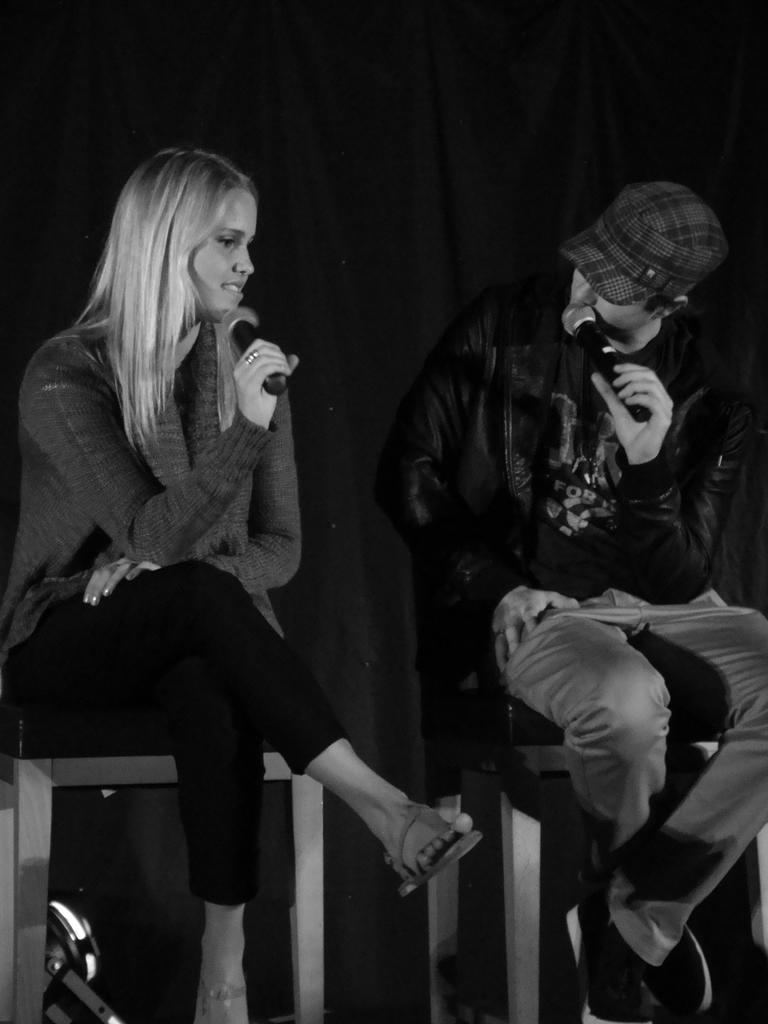How many people are in the image? There are two persons in the image. What are the persons doing in the image? The persons are sitting on chairs and holding microphones. What can be seen in the background of the image? There is a black curtain cloth in the background of the image. What type of texture can be seen on the microphones in the image? There is no information about the texture of the microphones in the image. 